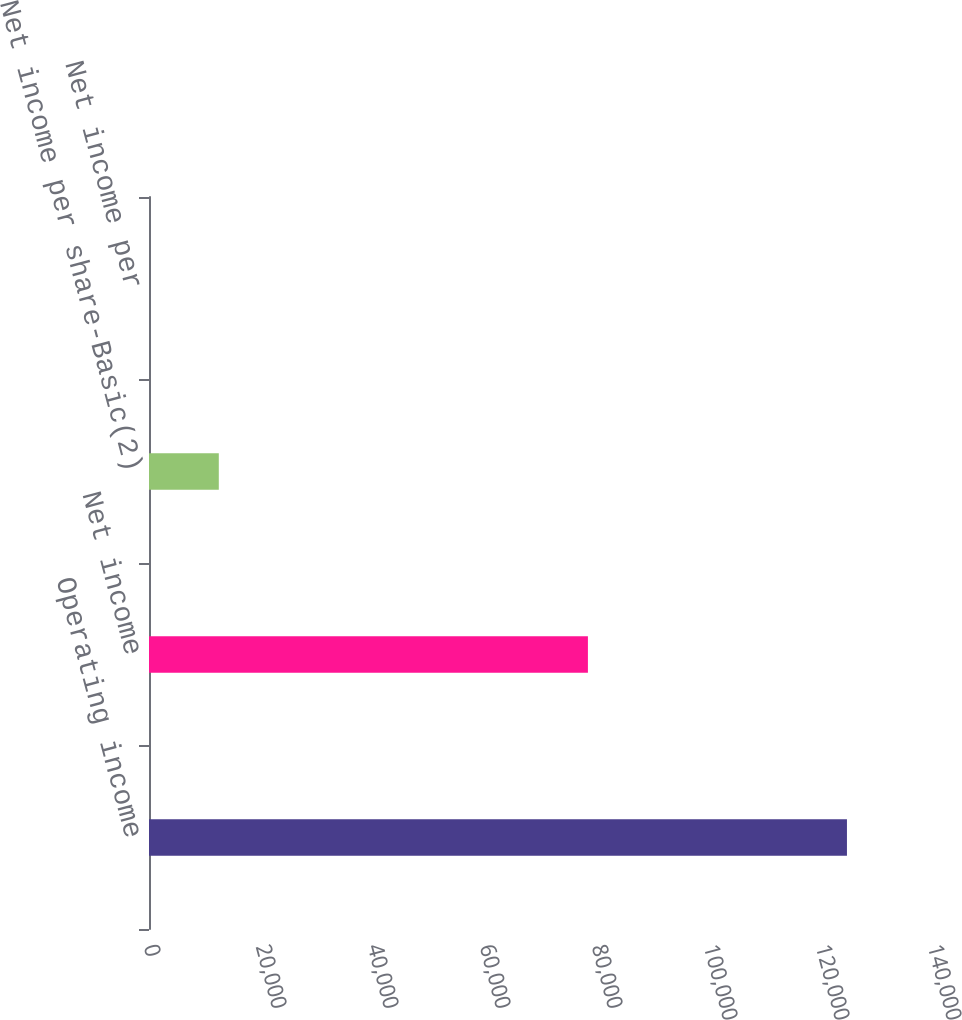Convert chart. <chart><loc_0><loc_0><loc_500><loc_500><bar_chart><fcel>Operating income<fcel>Net income<fcel>Net income per share-Basic(2)<fcel>Net income per<nl><fcel>124634<fcel>78377<fcel>12463.8<fcel>0.43<nl></chart> 